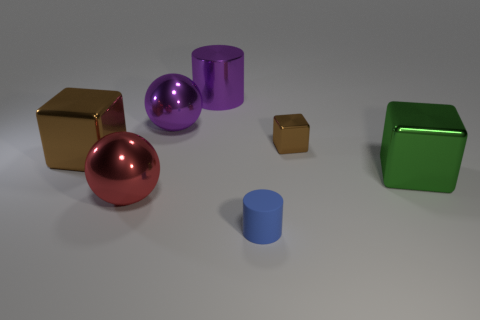There is a big cube that is the same color as the tiny cube; what is it made of?
Offer a terse response. Metal. What number of tiny brown metal things have the same shape as the large green object?
Offer a very short reply. 1. There is a big cube to the left of the blue thing; does it have the same color as the tiny object that is to the right of the blue cylinder?
Offer a terse response. Yes. What is the material of the cube that is the same size as the matte cylinder?
Make the answer very short. Metal. What number of other things are there of the same color as the large cylinder?
Your answer should be very brief. 1. Do the purple cylinder and the tiny brown cube have the same material?
Provide a succinct answer. Yes. There is a big object behind the big metal sphere on the right side of the large red shiny thing; what is its material?
Provide a succinct answer. Metal. What size is the purple thing left of the metallic cylinder?
Make the answer very short. Large. There is a metal object that is in front of the big brown metallic object and on the left side of the small brown metallic object; what color is it?
Offer a terse response. Red. There is a shiny sphere that is in front of the green block; is its size the same as the tiny brown block?
Your answer should be compact. No. 